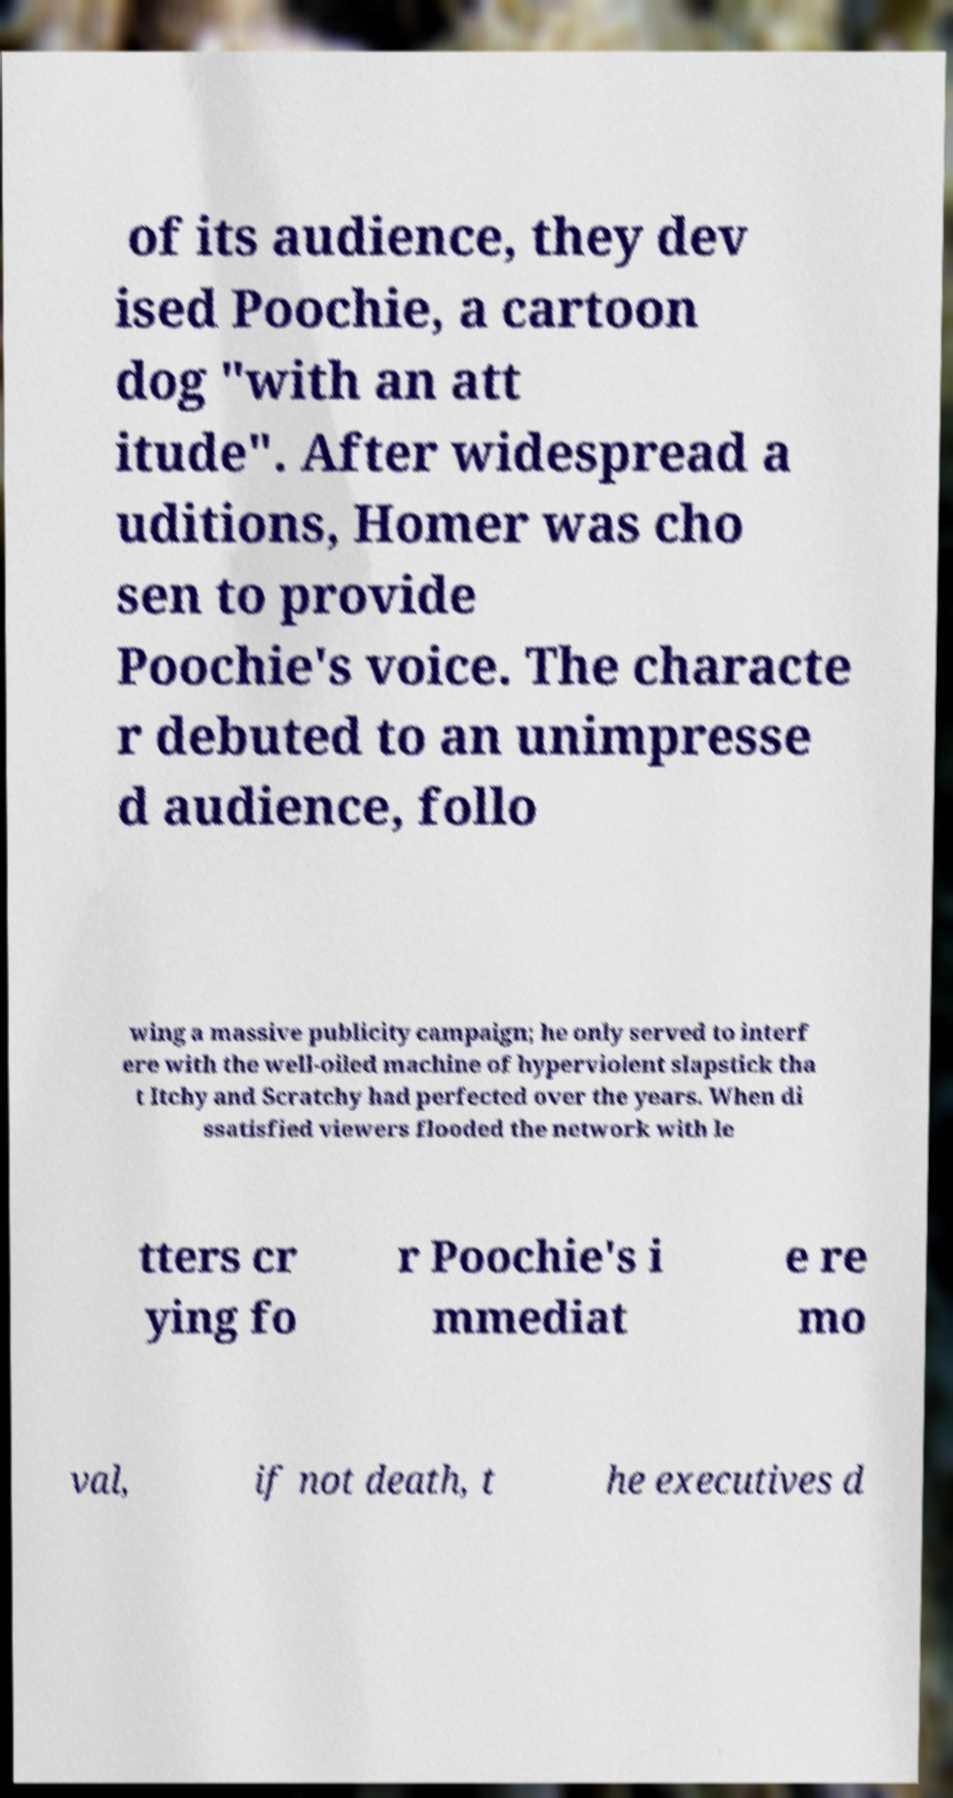Could you assist in decoding the text presented in this image and type it out clearly? of its audience, they dev ised Poochie, a cartoon dog "with an att itude". After widespread a uditions, Homer was cho sen to provide Poochie's voice. The characte r debuted to an unimpresse d audience, follo wing a massive publicity campaign; he only served to interf ere with the well-oiled machine of hyperviolent slapstick tha t Itchy and Scratchy had perfected over the years. When di ssatisfied viewers flooded the network with le tters cr ying fo r Poochie's i mmediat e re mo val, if not death, t he executives d 